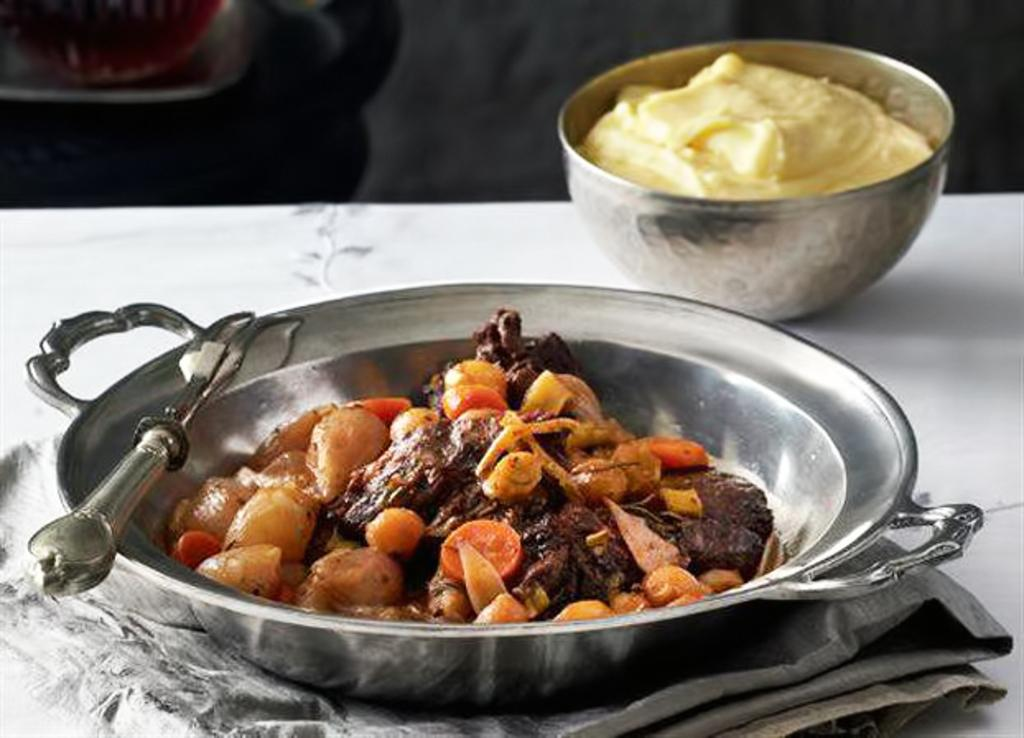What is present in the bowls in the image? There are food items in bowls in thels in the image. What utensil is visible in the image? There is a fork visible in the image. What is covered by the cloth in the image? The cloth is placed on an object in the image. How would you describe the background of the image? The background of the image is blurred. How many wilderness areas are visible in the image? There are no wilderness areas visible in the image; it features food items in bowls, a fork, and a cloth-covered object. What is the fifth item in the image? There is no fifth item in the image, as only four items have been mentioned: food items in bowls, a fork, a cloth-covered object, and a blurred background. 